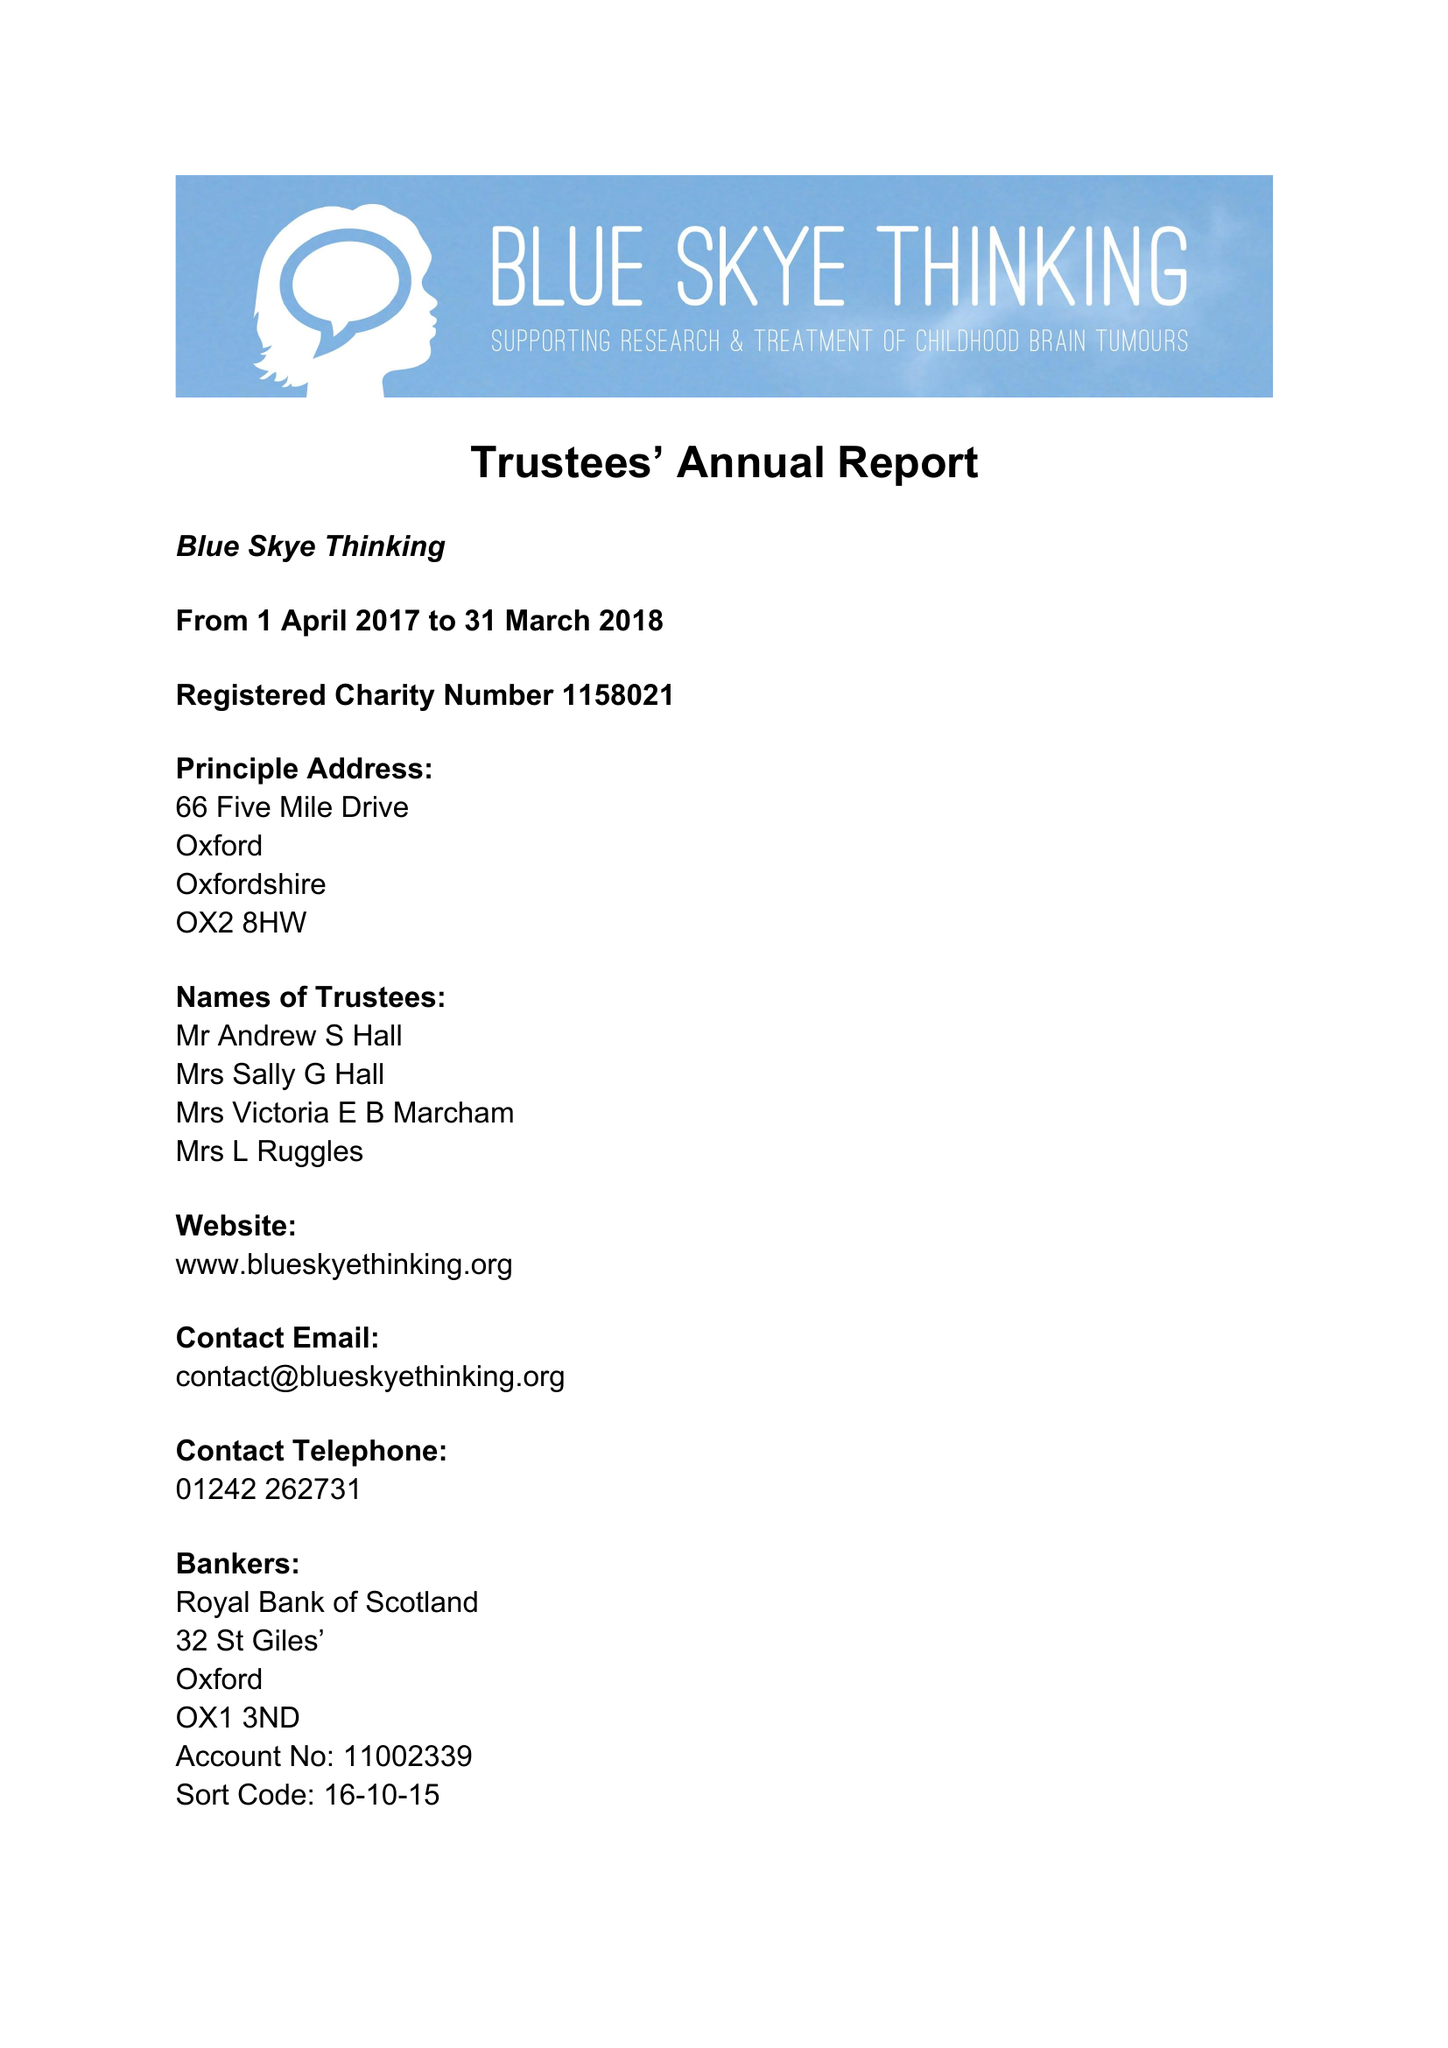What is the value for the charity_name?
Answer the question using a single word or phrase. Blue Skye Thinking 